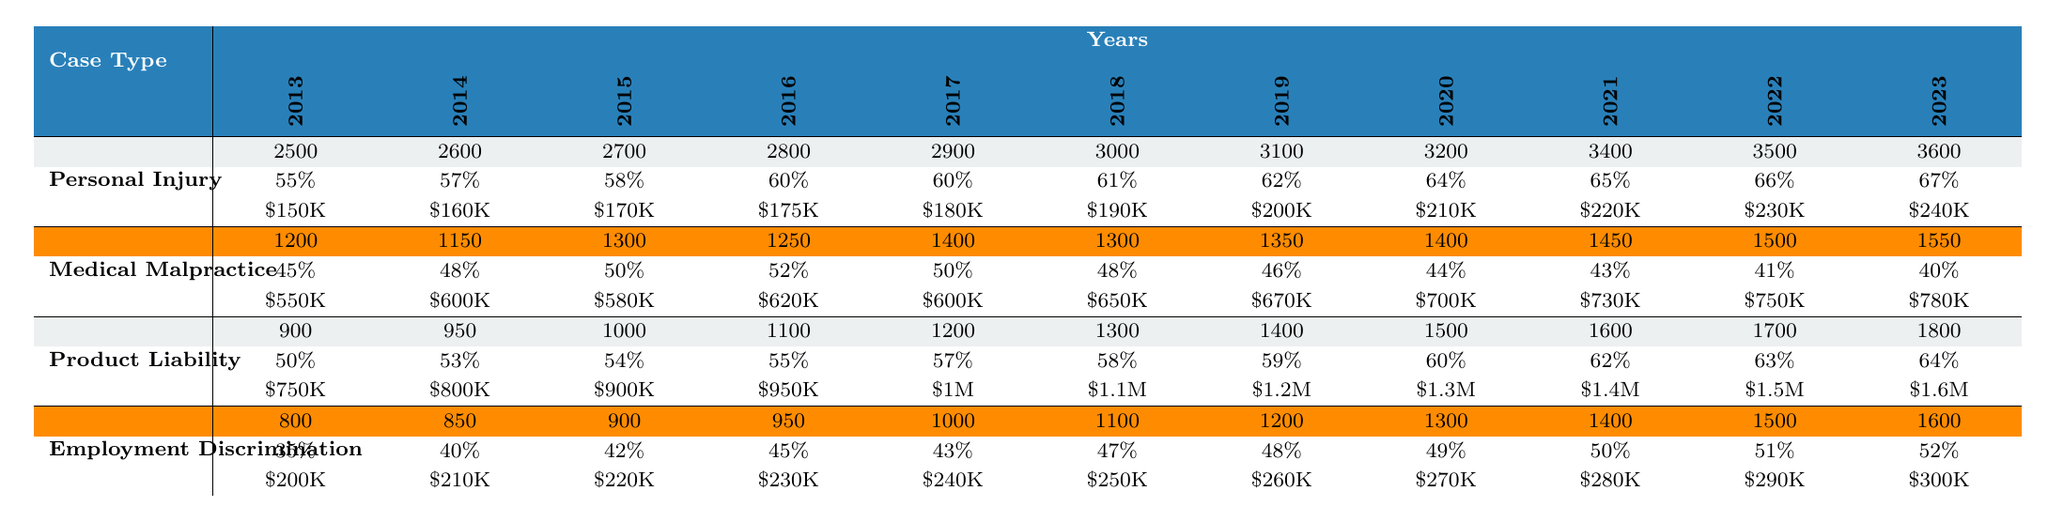What was the percentage of verdicts won in Personal Injury cases in 2020? In the table, under the Personal Injury row and the 2020 column, the percentage won is listed as 64%.
Answer: 64% What was the average award in Medical Malpractice cases in 2017? The average award for Medical Malpractice in 2017 is displayed in the table and is \$600,000.
Answer: \$600,000 How many Product Liability cases were there in 2019? Looking at the Product Liability row and the 2019 column, the number of verdicts is 1,400.
Answer: 1,400 Calculate the total number of Employment Discrimination verdicts from 2013 to 2023. Adding the values from the Employment Discrimination row across the years gives: 800 + 850 + 900 + 950 + 1000 + 1100 + 1200 + 1300 + 1400 + 1500 + 1600 = 11500.
Answer: 11,500 Was the average award for Product Liability cases higher in 2023 than in 2022? Checking the average awards for Product Liability, \$1.6 million in 2023 is greater than \$1.5 million in 2022, confirming that it is higher.
Answer: Yes How many more Personal Injury verdicts were there in 2021 compared to 2014? In 2021, there were 3,400 verdicts and in 2014, there were 2,600. The difference is 3,400 - 2,600 = 800.
Answer: 800 Identify the case type with the lowest winning percentage in 2022. Reviewing the winning percentages in 2022, Employment Discrimination at 51% is less than the others (Personal Injury 66%, Medical Malpractice 41%, Product Liability 63%), making it the lowest.
Answer: Employment Discrimination Which case type saw the highest average award in 2023? Among the average awards in 2023, Product Liability was \$1.6 million, which is the highest compared to Personal Injury (\$240,000), Medical Malpractice (\$780,000), and Employment Discrimination (\$300,000).
Answer: Product Liability What trend can be observed for the percentage won in Personal Injury cases from 2013 to 2023? The winning percentage increased steadily from 55% in 2013 to 67% in 2023, showing a clear upward trend over the ten years.
Answer: Increasing trend Which year had the highest number of verdicts in Medical Malpractice cases? Looking at the Medical Malpractice row, the highest number of verdicts occurs in 2017 with 1,400 verdicts.
Answer: 2017 